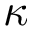Convert formula to latex. <formula><loc_0><loc_0><loc_500><loc_500>\kappa</formula> 